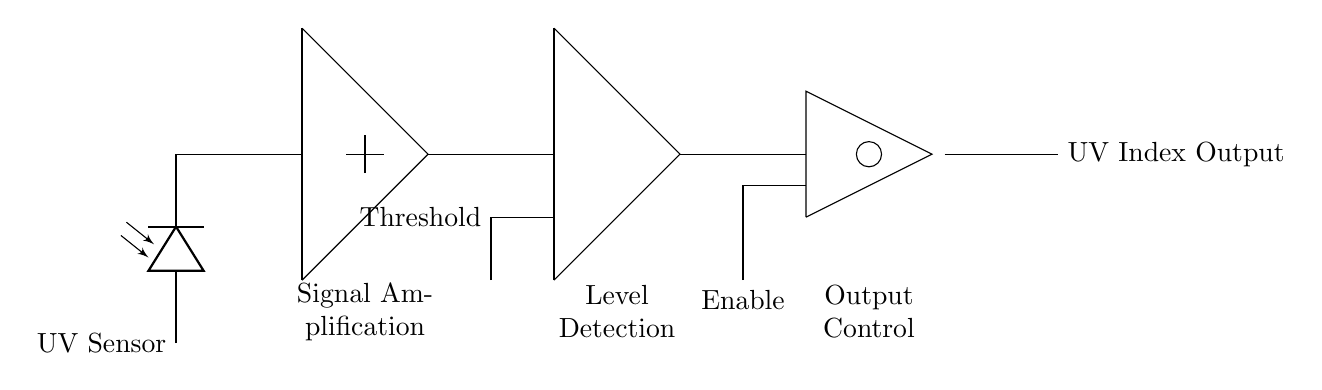What type of sensor is used in this circuit? The circuit includes a photodiode, which is a type of sensor that responds to light, specifically ultraviolet (UV) light in this case.
Answer: Photodiode What is the function of the amplifier in this circuit? The amplifier takes the weak photodiode signal and enhances its strength, allowing for better detection of the UV light levels. This function is indicated by the labeling "Signal Amplification."
Answer: Signal amplification What defines the threshold in the comparator section? The threshold in the comparator section is a reference level set to distinguish between low and high UV readings; it is labeled as "Threshold."
Answer: Threshold What type of logic gate is used after the comparator? An AND gate is employed in this circuit, depicted as a circular shape with two inputs leading to it. This gate combines signals based on specific criteria.
Answer: AND gate What do the two input connections to the AND gate signify? The two input connections represent the "Enable" signal and the output from the comparator, indicating that both conditions must be met for the output to be active.
Answer: Enable and Output from Comparator What is the final output of the circuit referred to as? The final output is labeled as "UV Index Output," indicating the measured level of UV exposure based on processed input signals.
Answer: UV Index Output 